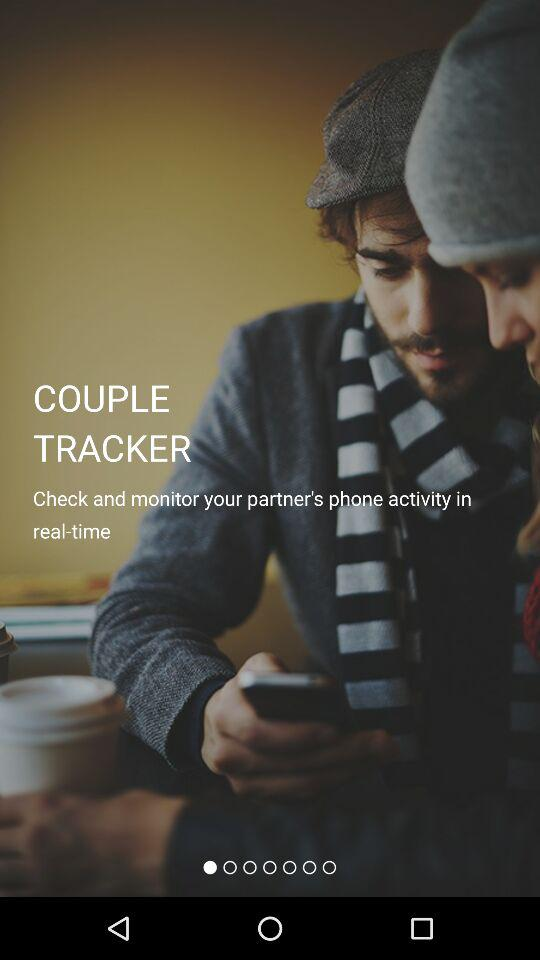What is the application name? The application name is "COUPLE TRACKER". 